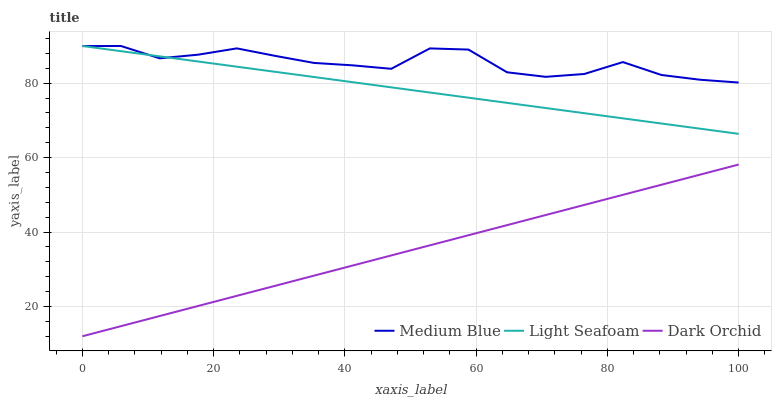Does Dark Orchid have the minimum area under the curve?
Answer yes or no. Yes. Does Medium Blue have the maximum area under the curve?
Answer yes or no. Yes. Does Medium Blue have the minimum area under the curve?
Answer yes or no. No. Does Dark Orchid have the maximum area under the curve?
Answer yes or no. No. Is Dark Orchid the smoothest?
Answer yes or no. Yes. Is Medium Blue the roughest?
Answer yes or no. Yes. Is Medium Blue the smoothest?
Answer yes or no. No. Is Dark Orchid the roughest?
Answer yes or no. No. Does Dark Orchid have the lowest value?
Answer yes or no. Yes. Does Medium Blue have the lowest value?
Answer yes or no. No. Does Medium Blue have the highest value?
Answer yes or no. Yes. Does Dark Orchid have the highest value?
Answer yes or no. No. Is Dark Orchid less than Medium Blue?
Answer yes or no. Yes. Is Light Seafoam greater than Dark Orchid?
Answer yes or no. Yes. Does Light Seafoam intersect Medium Blue?
Answer yes or no. Yes. Is Light Seafoam less than Medium Blue?
Answer yes or no. No. Is Light Seafoam greater than Medium Blue?
Answer yes or no. No. Does Dark Orchid intersect Medium Blue?
Answer yes or no. No. 